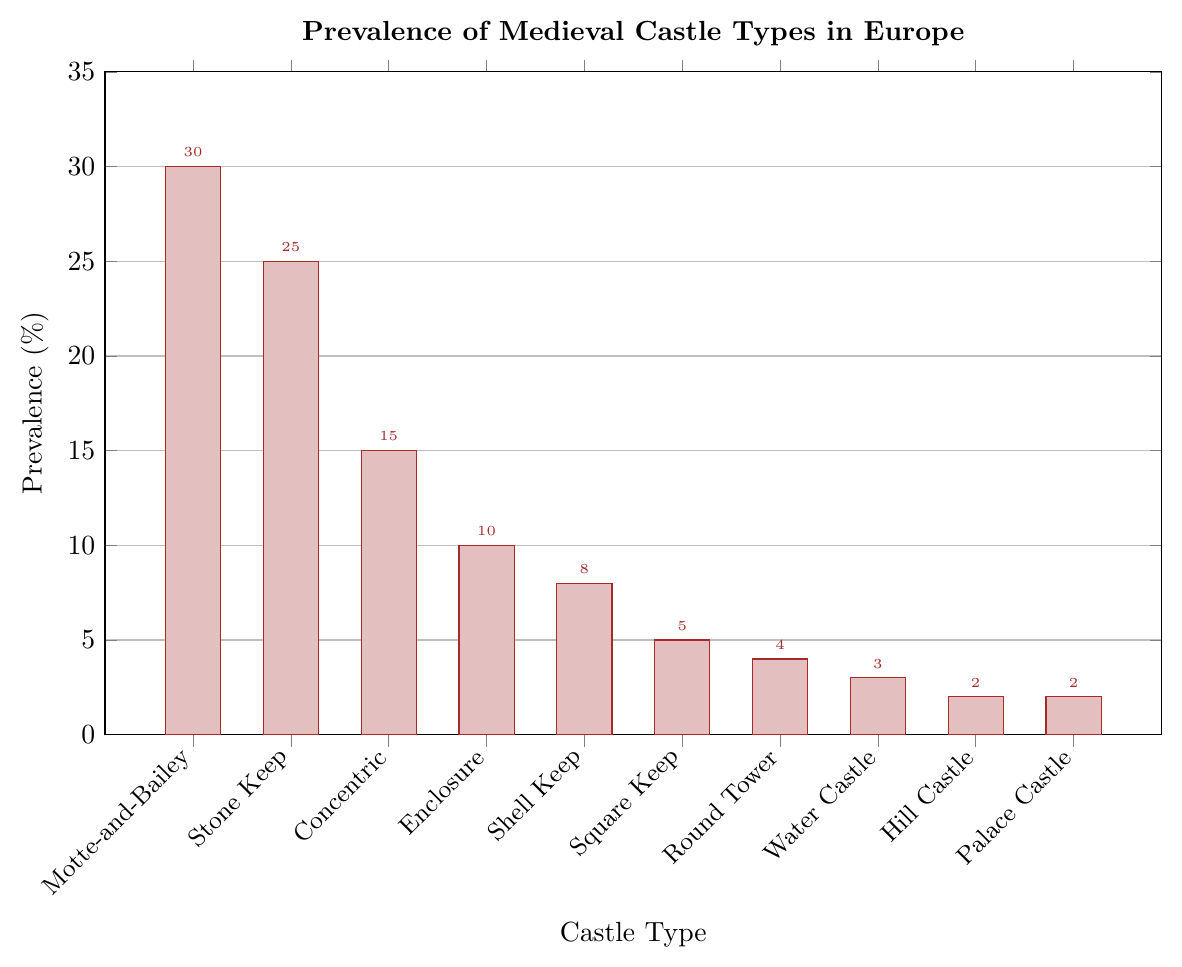Which castle type is the most prevalent in Europe? The bar corresponding to Motte-and-Bailey is the tallest, indicating that it is the most prevalent type.
Answer: Motte-and-Bailey Which two castle types have the least prevalence in Europe? The bars corresponding to Hill Castle and Palace Castle are the shortest, both reaching 2%.
Answer: Hill Castle and Palace Castle What is the combined prevalence of Stone Keep and Concentric castles? Stone Keep has a prevalence of 25%, and Concentric has 15%. Adding these, we get 25% + 15% = 40%.
Answer: 40% Which castle type is more prevalent: Water Castle or Round Tower? The bar for Round Tower is slightly taller than the bar for Water Castle. Round Tower has 4%, while Water Castle has 3%.
Answer: Round Tower How much lower is the prevalence of Square Keep castles compared to Motte-and-Bailey castles? The bar for Motte-and-Bailey is 30%, while the bar for Square Keep is 5%. The difference is 30% - 5% = 25%.
Answer: 25% What is the total prevalence of all castle types with less than 10% prevalence? The prevalence values for Shell Keep (8%), Square Keep (5%), Round Tower (4%), Water Castle (3%), Hill Castle (2%), and Palace Castle (2%) need to be added together. 8% + 5% + 4% + 3% + 2% + 2% = 24%.
Answer: 24% Is Enclosure castle more or less prevalent than Shell Keep castle? The bar for Enclosure is taller than that for Shell Keep. Enclosure has a prevalence of 10%, while Shell Keep has 8%.
Answer: More What is the average prevalence of the top three most prevalent castle types? The prevalence values for the top three castle types are Motte-and-Bailey (30%), Stone Keep (25%), and Concentric (15%). The average is (30% + 25% + 15%) / 3 = 70% / 3 ≈ 23.33%.
Answer: 23.33% Which castle type on the chart has a prevalence closest to 5%? The bar corresponding to Square Keep reaches exactly 5%.
Answer: Square Keep Between Concentric and Enclosure castles, which has a higher prevalence, and by how much? Concentric has a prevalence of 15%, and Enclosure has a prevalence of 10%. The difference is 15% - 10% = 5%.
Answer: Concentric, by 5% 